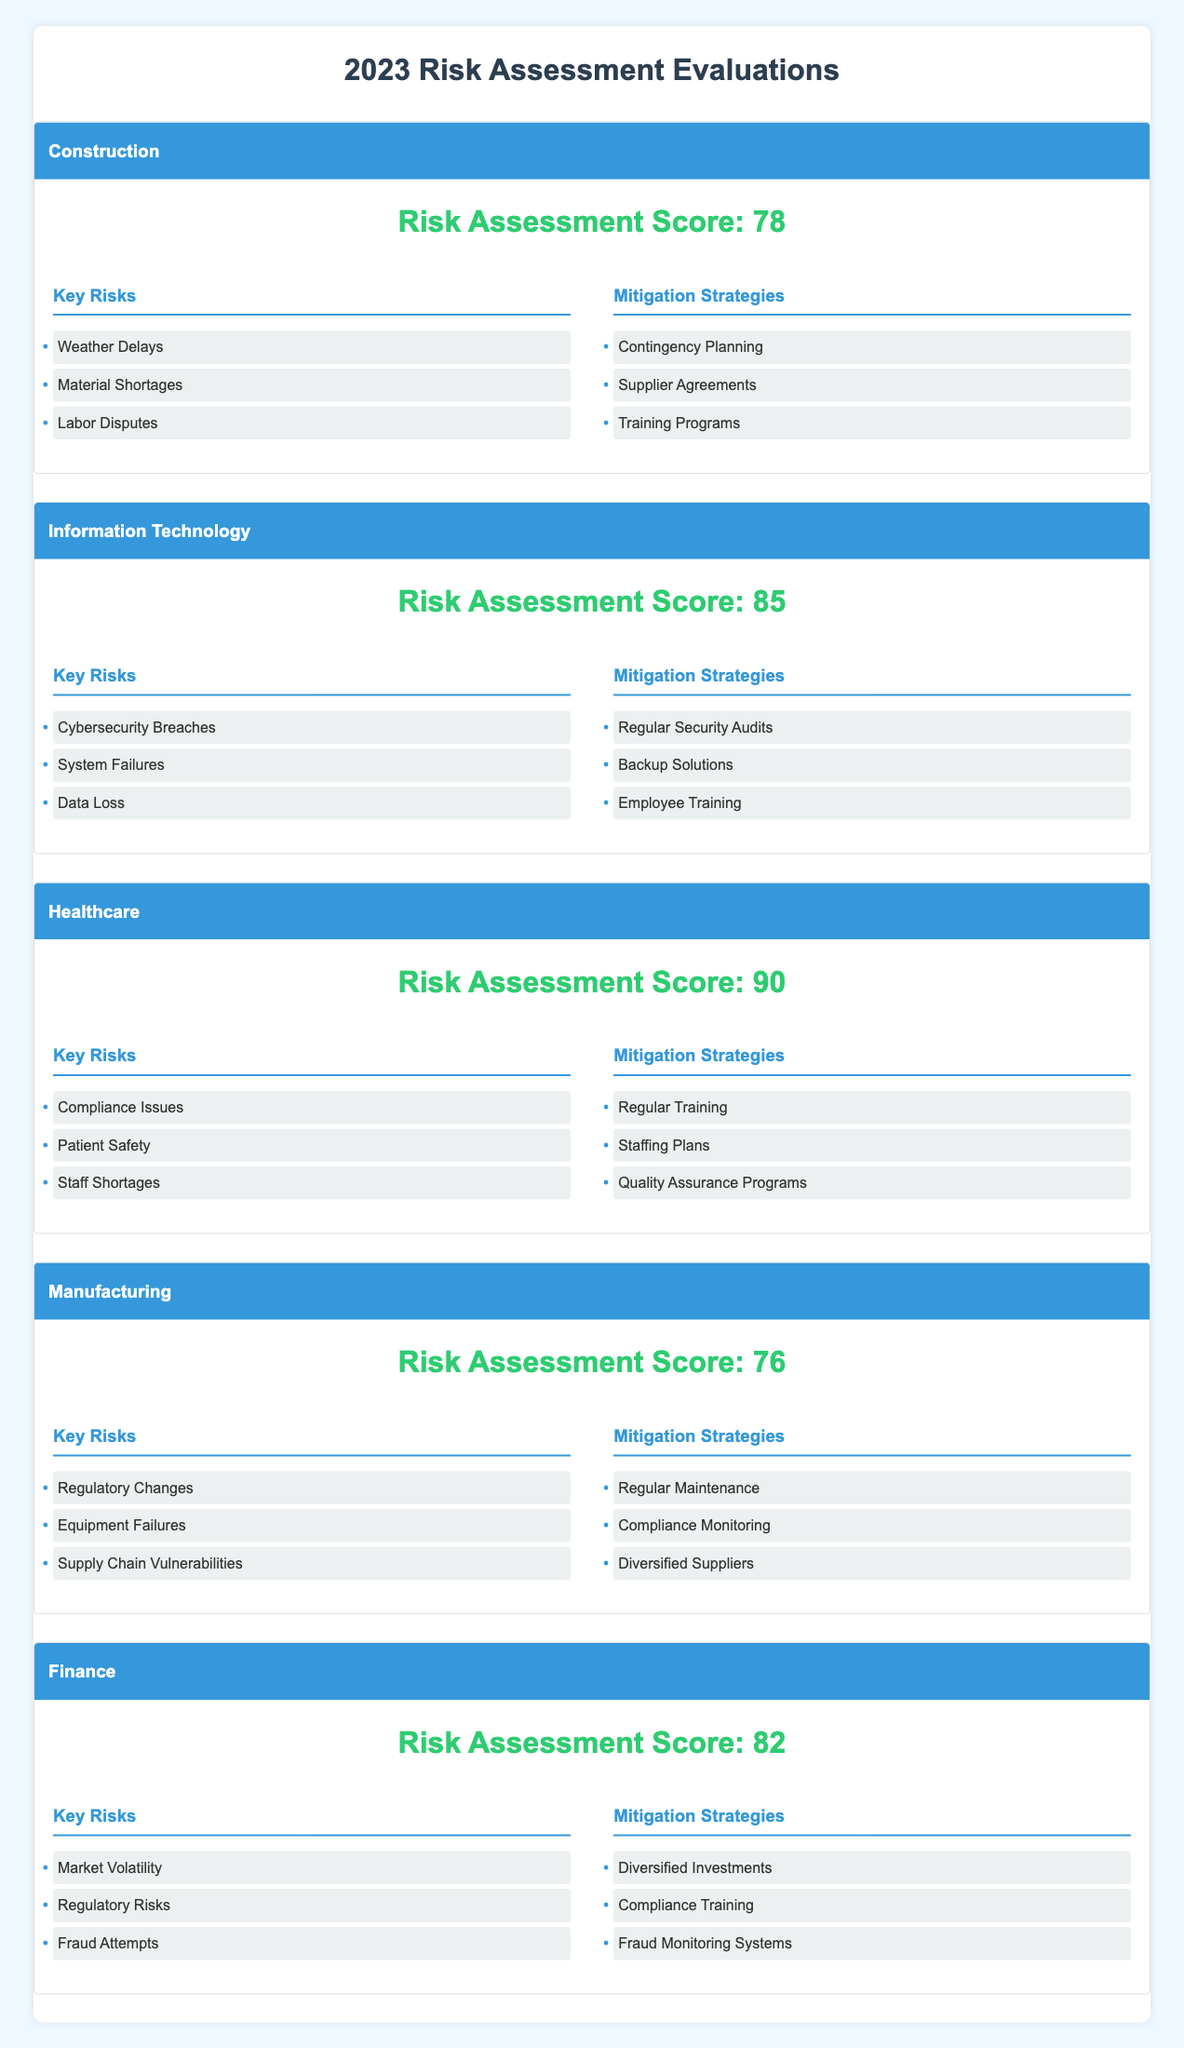What is the highest risk assessment score among the project types? To find the highest risk assessment score, we compare the scores for each project type: Construction (78), Information Technology (85), Healthcare (90), Manufacturing (76), and Finance (82). The highest score is 90 from the Healthcare project type.
Answer: 90 What are the key risks for the Information Technology project type? The key risks for the Information Technology project type, as listed in the table, are: Cybersecurity Breaches, System Failures, and Data Loss.
Answer: Cybersecurity Breaches, System Failures, Data Loss Which project type has the lowest risk assessment score? Upon examining the risk assessment scores, we see that Manufacturing has the lowest score at 76 when compared to the others: Construction (78), Information Technology (85), Healthcare (90), and Finance (82).
Answer: Manufacturing What is the average risk assessment score of all project types? To calculate the average, we add the scores of all project types: 78 (Construction) + 85 (IT) + 90 (Healthcare) + 76 (Manufacturing) + 82 (Finance) = 411. Then, we divide by the number of project types (5), which gives us 411 / 5 = 82.2.
Answer: 82.2 Is there a project type that lists "Staff Shortages" as a key risk? Looking at the key risks listed, only the Healthcare project type includes "Staff Shortages" among its key risks. Therefore, the answer is true; it does list that risk.
Answer: Yes How many unique mitigation strategies are mentioned across all project types? By reviewing the mitigation strategies for each project type, we list them: Construction (3), Information Technology (3), Healthcare (3), Manufacturing (3), and Finance (3). Each project type has three strategies, but there may be overlaps. After examining, we find the unique strategies: Contingency Planning, Supplier Agreements, Training Programs, Regular Security Audits, Backup Solutions, Employee Training, Regular Training, Staffing Plans, Quality Assurance Programs, Regular Maintenance, Compliance Monitoring, Diversified Suppliers, Diversified Investments, Compliance Training, and Fraud Monitoring Systems. This gives us a total of 15 unique strategies.
Answer: 15 Which project type has the highest score, and what is its key risk related to safety? The project type with the highest score is Healthcare (90). Among its key risks, “Patient Safety” specifically relates to safety concerns, making it significant for this project type.
Answer: Healthcare, Patient Safety What are three common key risks shared across project types? By reviewing the listed key risks for all project types, we can identify overlapping themes. However, the specific risks listed do not show three common ones among all types. Each project has its unique risks. So, there isn't a set of common risks shared.
Answer: None 